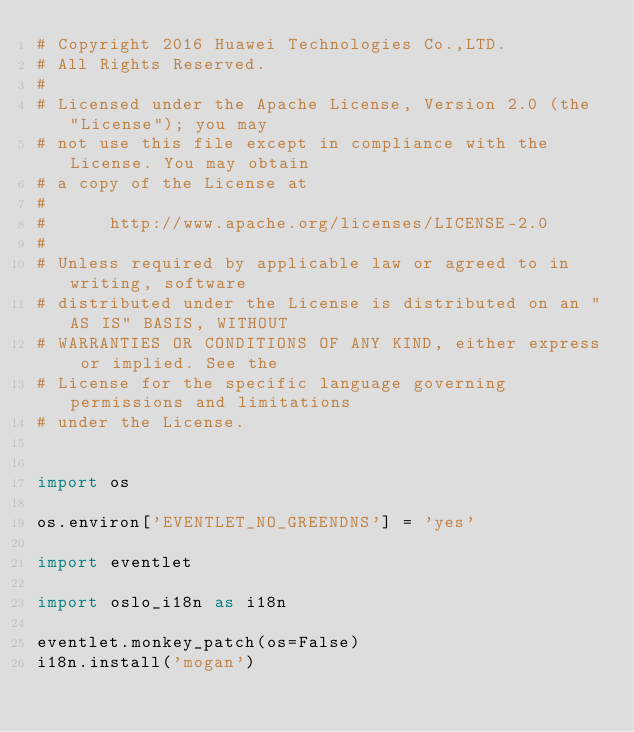Convert code to text. <code><loc_0><loc_0><loc_500><loc_500><_Python_># Copyright 2016 Huawei Technologies Co.,LTD.
# All Rights Reserved.
#
# Licensed under the Apache License, Version 2.0 (the "License"); you may
# not use this file except in compliance with the License. You may obtain
# a copy of the License at
#
#      http://www.apache.org/licenses/LICENSE-2.0
#
# Unless required by applicable law or agreed to in writing, software
# distributed under the License is distributed on an "AS IS" BASIS, WITHOUT
# WARRANTIES OR CONDITIONS OF ANY KIND, either express or implied. See the
# License for the specific language governing permissions and limitations
# under the License.


import os

os.environ['EVENTLET_NO_GREENDNS'] = 'yes'

import eventlet

import oslo_i18n as i18n

eventlet.monkey_patch(os=False)
i18n.install('mogan')
</code> 